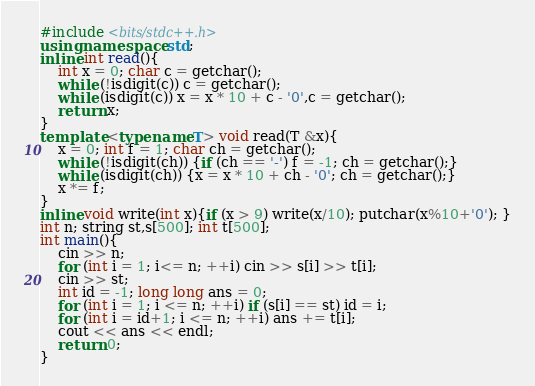Convert code to text. <code><loc_0><loc_0><loc_500><loc_500><_C++_>#include <bits/stdc++.h>
using namespace std;
inline int read(){
    int x = 0; char c = getchar();
    while (!isdigit(c)) c = getchar();
    while (isdigit(c)) x = x * 10 + c - '0',c = getchar();
    return x;
}
template <typename T> void read(T &x){
	x = 0; int f = 1; char ch = getchar();
	while (!isdigit(ch)) {if (ch == '-') f = -1; ch = getchar();}
	while (isdigit(ch)) {x = x * 10 + ch - '0'; ch = getchar();}
	x *= f;
}
inline void write(int x){if (x > 9) write(x/10); putchar(x%10+'0'); }
int n; string st,s[500]; int t[500];
int main(){
	cin >> n;
	for (int i = 1; i<= n; ++i) cin >> s[i] >> t[i];
	cin >> st; 
	int id = -1; long long ans = 0;
	for (int i = 1; i <= n; ++i) if (s[i] == st) id = i;
	for (int i = id+1; i <= n; ++i) ans += t[i];
	cout << ans << endl;
    return 0;
}
</code> 